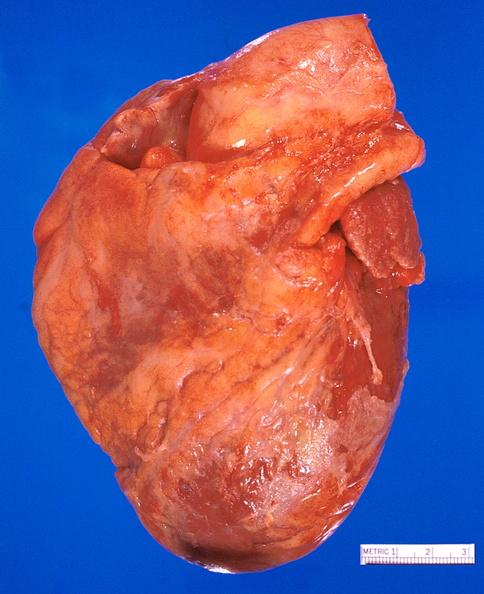s cardiovascular present?
Answer the question using a single word or phrase. Yes 